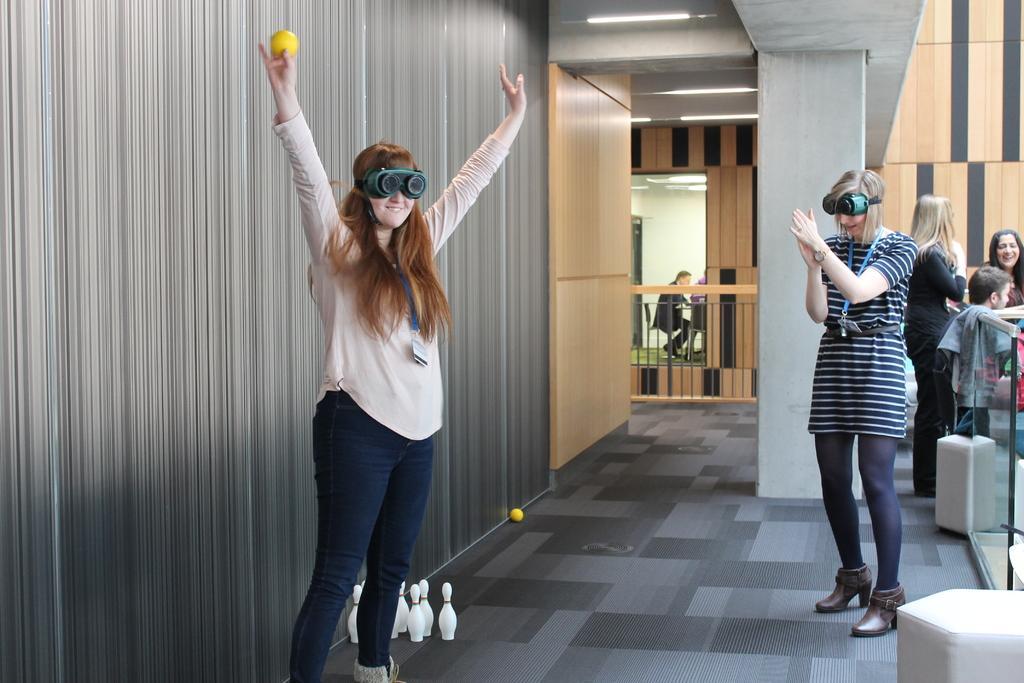Please provide a concise description of this image. In the background we can see a person sitting on a chair and the wall. On the right side of the picture we can see the people, glass railing. In this picture we can see the women wearing virtual glasses and a woman on the left side is holding a yellow ball. At the bottom portion of the picture we can see yellow bowl and bowling pins on the floor. 